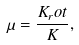<formula> <loc_0><loc_0><loc_500><loc_500>\mu = \frac { K _ { r } o t } { K } ,</formula> 